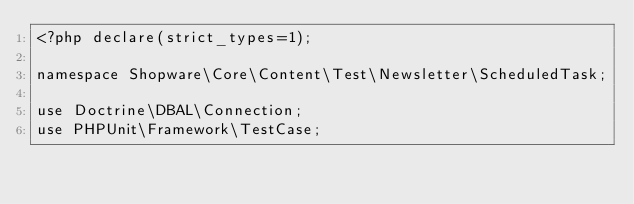<code> <loc_0><loc_0><loc_500><loc_500><_PHP_><?php declare(strict_types=1);

namespace Shopware\Core\Content\Test\Newsletter\ScheduledTask;

use Doctrine\DBAL\Connection;
use PHPUnit\Framework\TestCase;</code> 